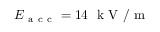Convert formula to latex. <formula><loc_0><loc_0><loc_500><loc_500>E _ { a c c } = 1 4 \ k V / m</formula> 